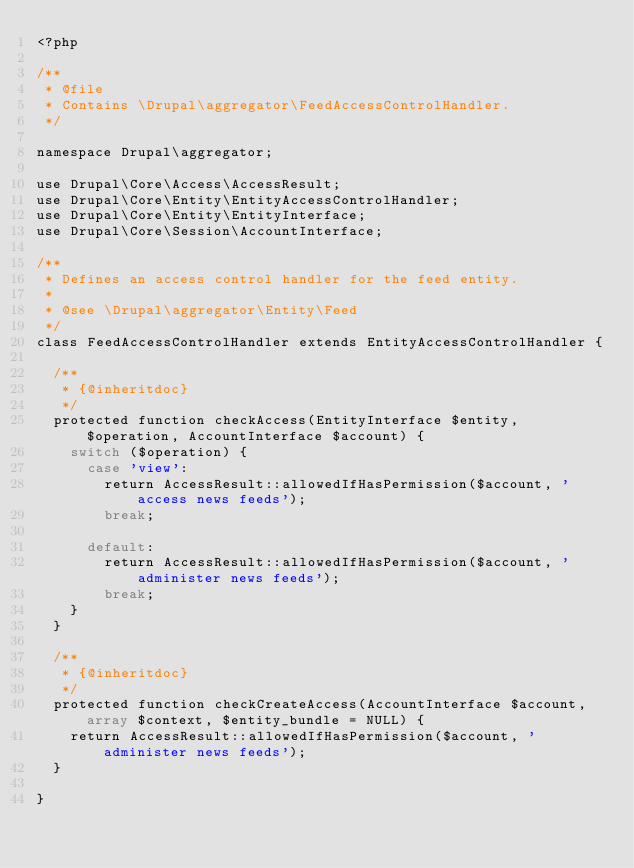<code> <loc_0><loc_0><loc_500><loc_500><_PHP_><?php

/**
 * @file
 * Contains \Drupal\aggregator\FeedAccessControlHandler.
 */

namespace Drupal\aggregator;

use Drupal\Core\Access\AccessResult;
use Drupal\Core\Entity\EntityAccessControlHandler;
use Drupal\Core\Entity\EntityInterface;
use Drupal\Core\Session\AccountInterface;

/**
 * Defines an access control handler for the feed entity.
 *
 * @see \Drupal\aggregator\Entity\Feed
 */
class FeedAccessControlHandler extends EntityAccessControlHandler {

  /**
   * {@inheritdoc}
   */
  protected function checkAccess(EntityInterface $entity, $operation, AccountInterface $account) {
    switch ($operation) {
      case 'view':
        return AccessResult::allowedIfHasPermission($account, 'access news feeds');
        break;

      default:
        return AccessResult::allowedIfHasPermission($account, 'administer news feeds');
        break;
    }
  }

  /**
   * {@inheritdoc}
   */
  protected function checkCreateAccess(AccountInterface $account, array $context, $entity_bundle = NULL) {
    return AccessResult::allowedIfHasPermission($account, 'administer news feeds');
  }

}
</code> 